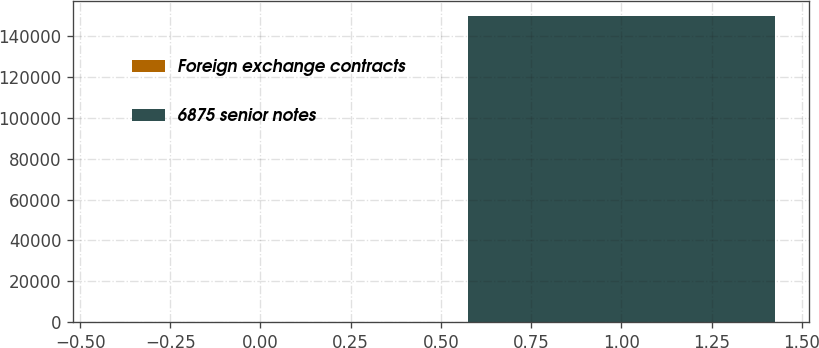Convert chart. <chart><loc_0><loc_0><loc_500><loc_500><bar_chart><fcel>Foreign exchange contracts<fcel>6875 senior notes<nl><fcel>110<fcel>150000<nl></chart> 